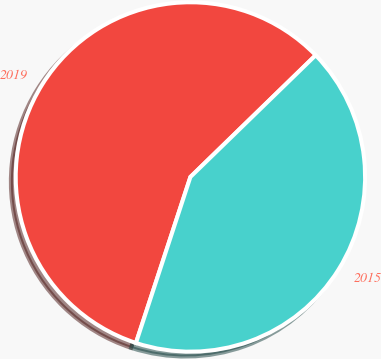Convert chart. <chart><loc_0><loc_0><loc_500><loc_500><pie_chart><fcel>2019<fcel>2015<nl><fcel>57.68%<fcel>42.32%<nl></chart> 